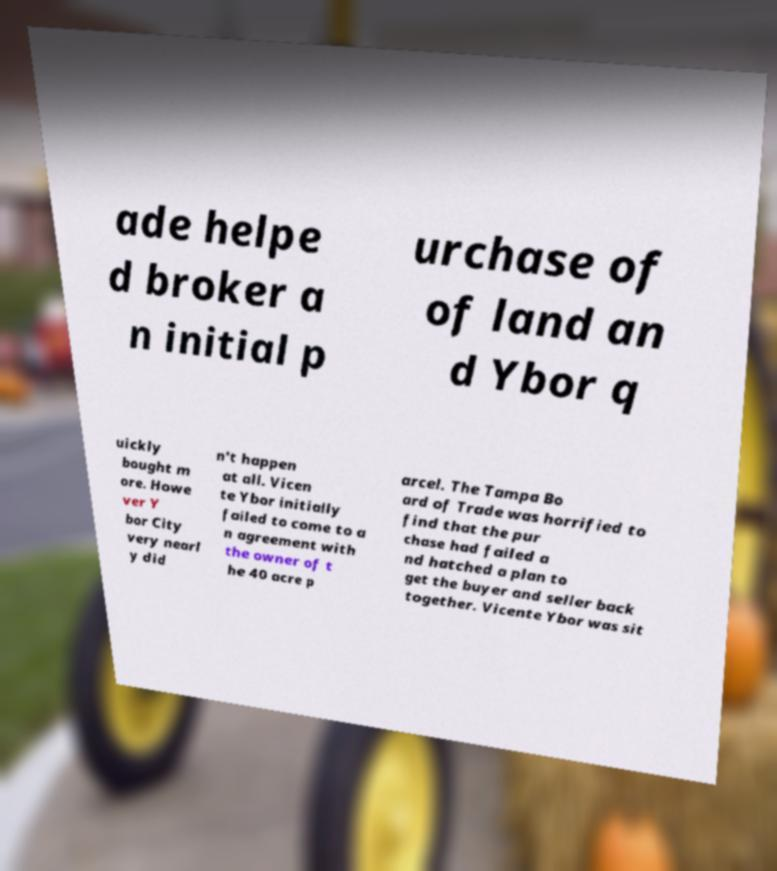What messages or text are displayed in this image? I need them in a readable, typed format. ade helpe d broker a n initial p urchase of of land an d Ybor q uickly bought m ore. Howe ver Y bor City very nearl y did n't happen at all. Vicen te Ybor initially failed to come to a n agreement with the owner of t he 40 acre p arcel. The Tampa Bo ard of Trade was horrified to find that the pur chase had failed a nd hatched a plan to get the buyer and seller back together. Vicente Ybor was sit 